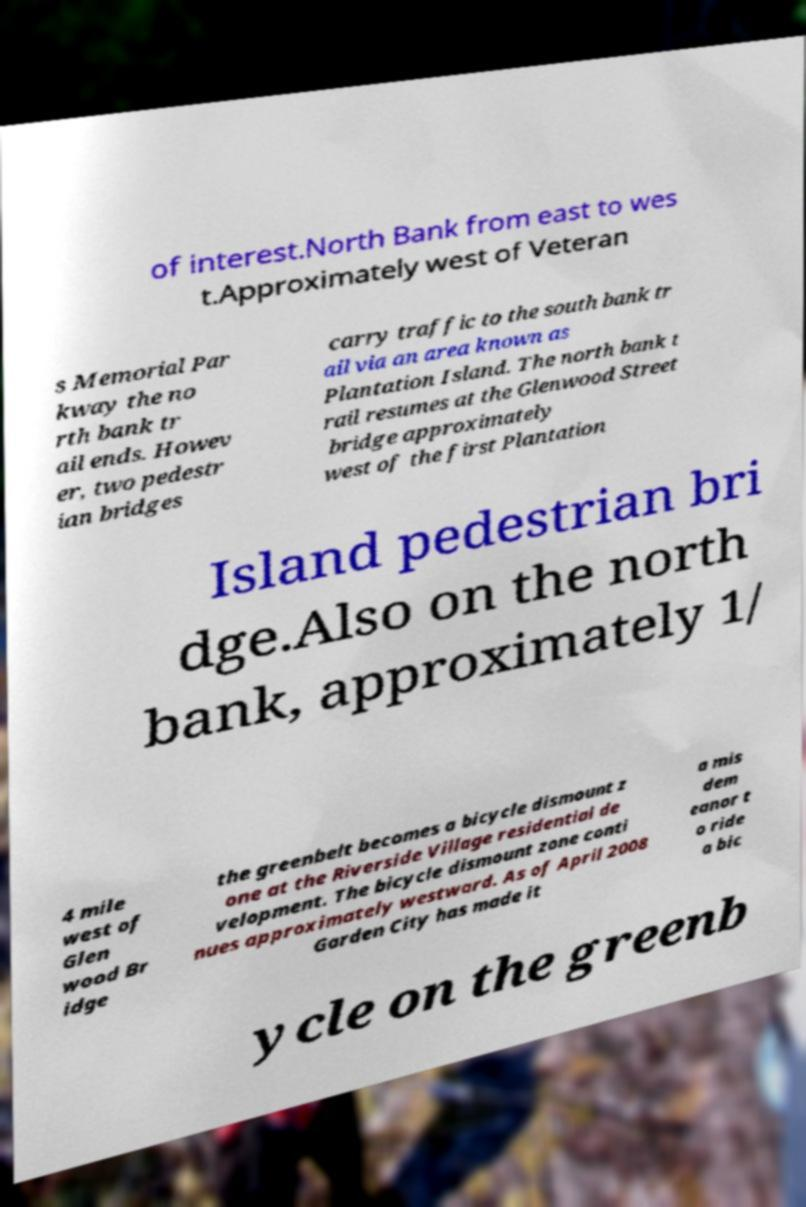For documentation purposes, I need the text within this image transcribed. Could you provide that? of interest.North Bank from east to wes t.Approximately west of Veteran s Memorial Par kway the no rth bank tr ail ends. Howev er, two pedestr ian bridges carry traffic to the south bank tr ail via an area known as Plantation Island. The north bank t rail resumes at the Glenwood Street bridge approximately west of the first Plantation Island pedestrian bri dge.Also on the north bank, approximately 1/ 4 mile west of Glen wood Br idge the greenbelt becomes a bicycle dismount z one at the Riverside Village residential de velopment. The bicycle dismount zone conti nues approximately westward. As of April 2008 Garden City has made it a mis dem eanor t o ride a bic ycle on the greenb 